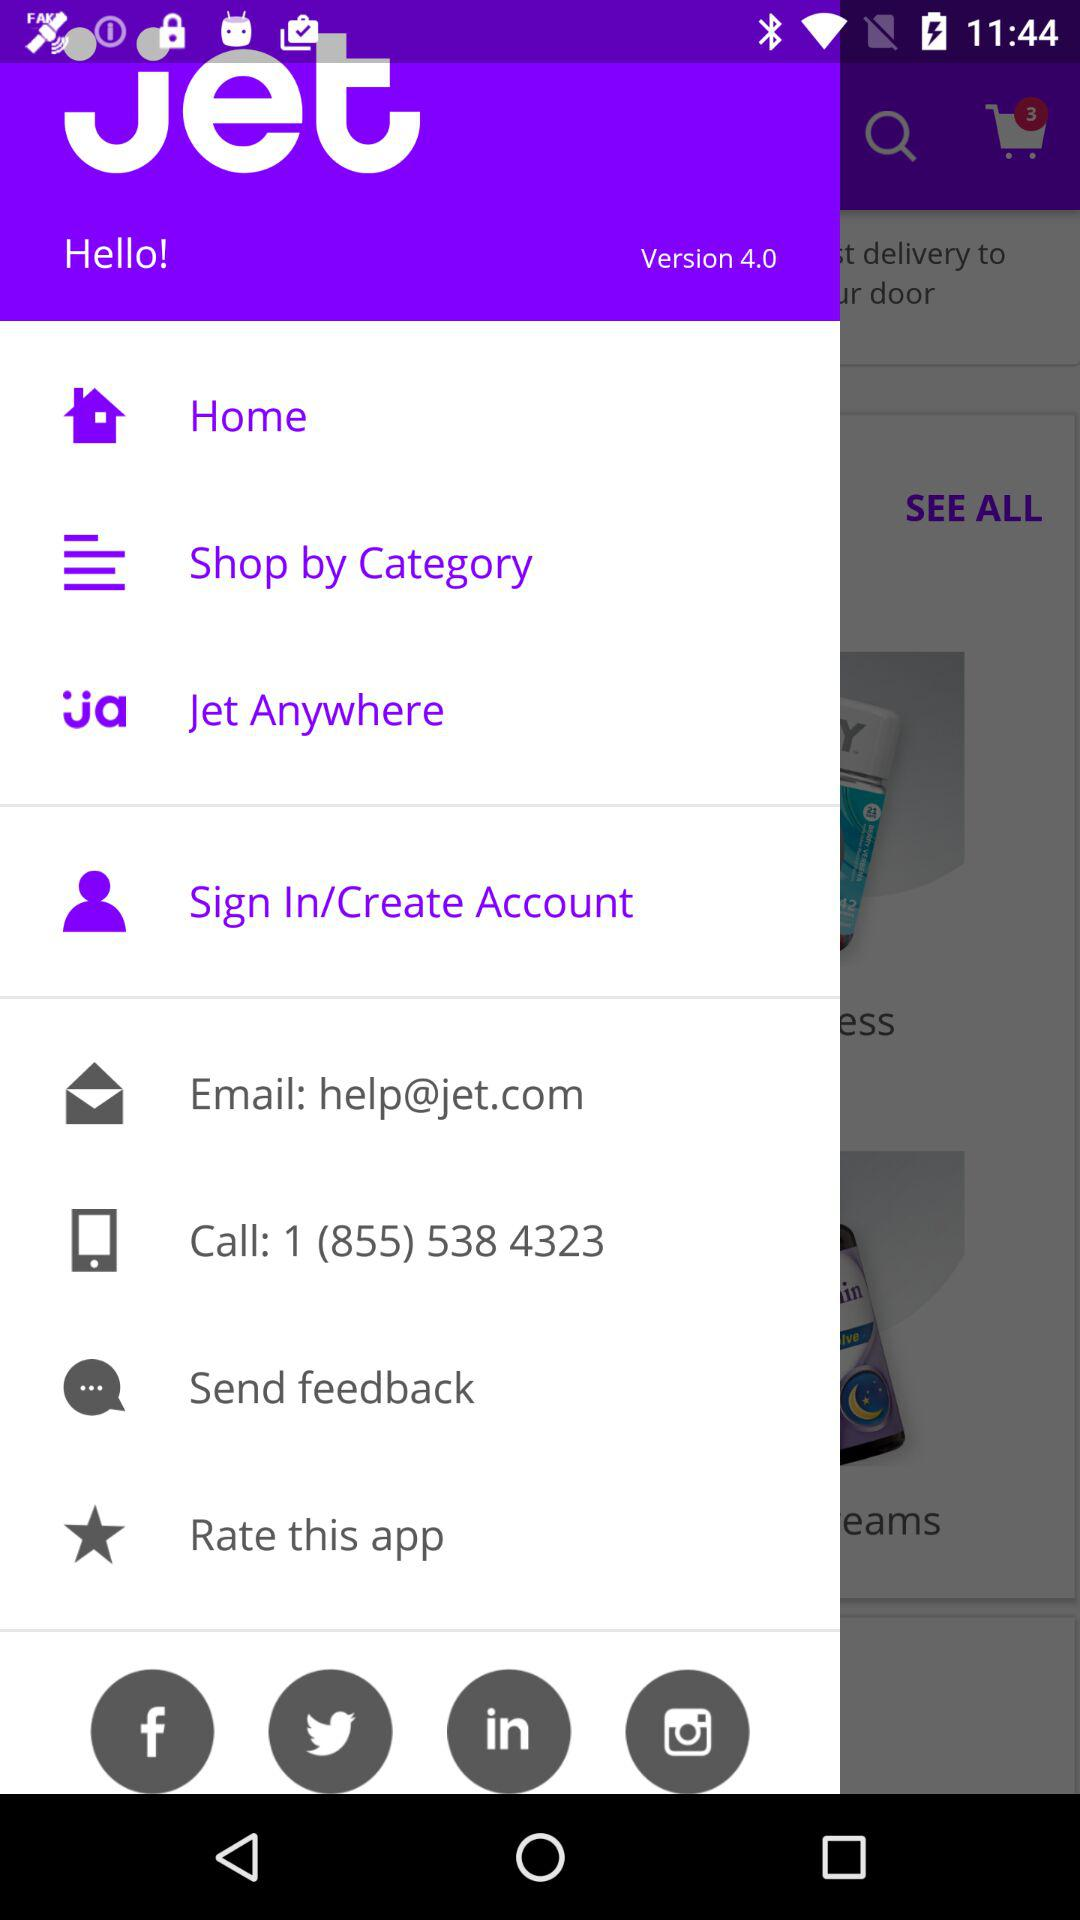What is the contact number? The contact number is 1 (855) 538 4323. 